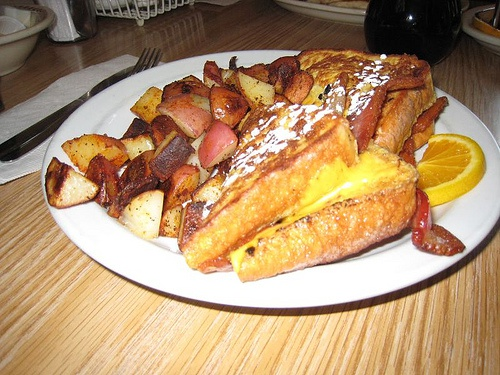Describe the objects in this image and their specific colors. I can see dining table in white, tan, maroon, and black tones, sandwich in black, orange, gold, and khaki tones, sandwich in black, brown, maroon, tan, and white tones, orange in black, orange, gold, khaki, and olive tones, and bowl in black and gray tones in this image. 